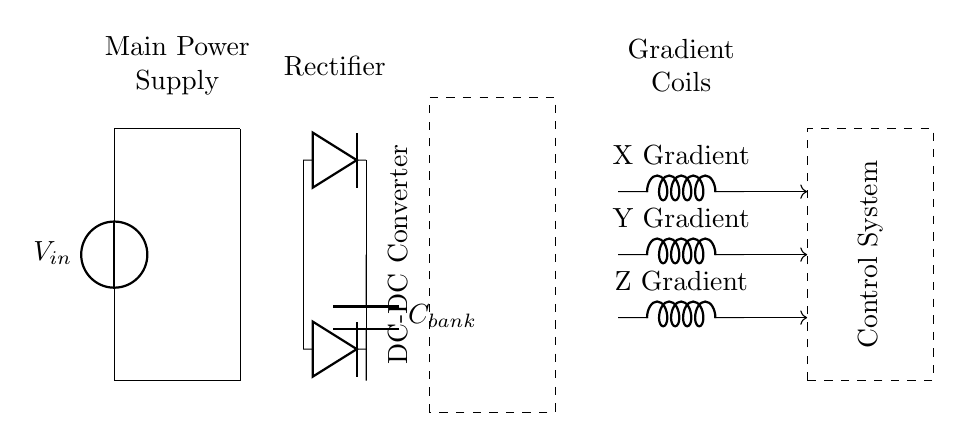What type of power supply is used in this circuit? The circuit uses a main power supply, indicated at the top of the diagram as "Main Power Supply."
Answer: Main Power Supply What component converts AC to DC in the circuit? The rectifier, which consists of two diodes shown in parallel, is responsible for converting alternating current (AC) into direct current (DC).
Answer: Rectifier What does the capacitor bank do? The capacitor bank smooths out the DC output by storing charge and releasing it when needed, ensuring stable voltage for the gradient coils.
Answer: Store charge How many gradient coils are present in the circuit? There are three gradient coils labeled X Gradient, Y Gradient, and Z Gradient, all indicated in the circuit diagram.
Answer: Three What is the purpose of the DC-DC converter in the circuit? The DC-DC Converter steps up or down the voltage levels needed for the gradient coils to function optimally based on control signals.
Answer: Adjust voltage What is the relationship between gradient coils and the control system? The gradient coils receive control signals from the control system, as indicated by the feedback lines connecting them in the diagram.
Answer: Control signals What type of inductors are used in the circuit for the gradient coils? The inductors for the gradient coils are labeled simply as inductors, indicating they are used to create the magnetic fields necessary for MRI imaging.
Answer: Inductors 